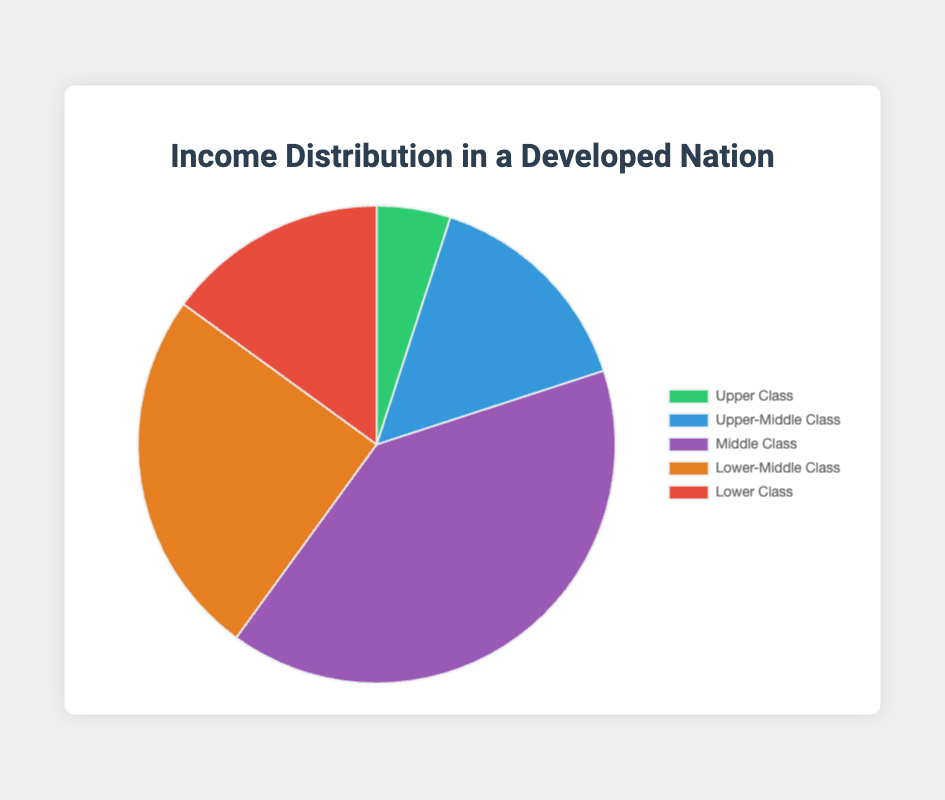What percentage of the income distribution does the middle class represent? From the figure, we can directly observe that the middle class represents 40% of the income distribution.
Answer: 40% What is the combined percentage of the upper-middle class and lower class? From the figure, the upper-middle class is 15% and the lower class is also 15%. Adding these two values gives 15% + 15% = 30%.
Answer: 30% Which class has the smallest share of the income distribution, and what is that share? By examining the figure, the upper class has the smallest share of the income distribution at 5%.
Answer: Upper Class, 5% How much more of the income distribution does the middle class constitute compared to the upper class? The middle class is 40% and the upper class is 5%. The difference is 40% - 5% = 35%.
Answer: 35% Are there any classes that represent an equal percentage in the income distribution? If yes, which ones? The figure shows that both the upper-middle class and the lower class represent 15% of the income distribution.
Answer: Upper-Middle Class and Lower Class What percentage of the income distribution is represented by the lower-middle class and lower class combined? The lower-middle class is 25% and the lower class is 15%. Adding these together gives 25% + 15% = 40%.
Answer: 40% Which class represents a quarter of the income distribution, and does any class represent more? The lower-middle class represents 25% of the income distribution. The middle class represents more with 40%.
Answer: Lower-Middle Class, Yes How does the upper-middle class's share compare to that of the lower-middle class? The upper-middle class represents 15%, and the lower-middle class represents 25%. The upper-middle class's share is 10% less than the lower-middle class.
Answer: 10% less What's the total percentage of the upper-middle class and middle class combined? The upper-middle class is 15% and the middle class is 40%. Adding these gives 15% + 40% = 55%.
Answer: 55% Visually, which segment of the pie chart is the largest, and which color is it? The middle class segment is the largest in the pie chart, and it is represented by the color purple.
Answer: Middle Class, Purple 